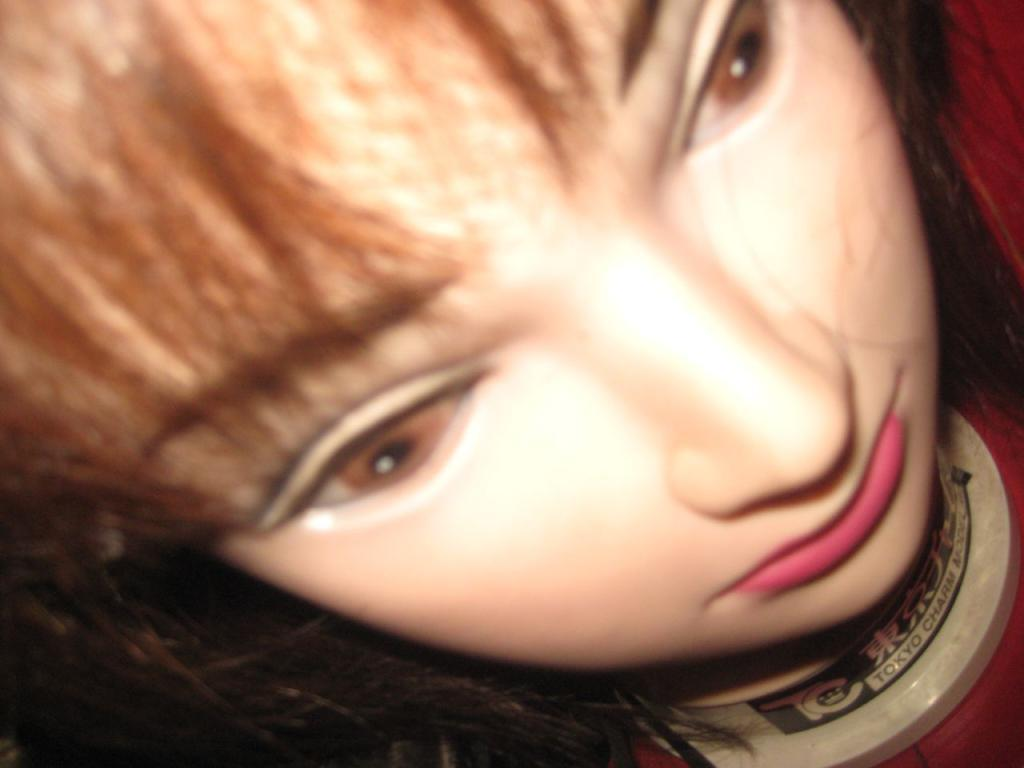What is the main subject in the image? There is a doll in the image. How many cats are sitting on the wrist of the doll in the image? There are no cats present in the image, and the doll does not have a wrist. 